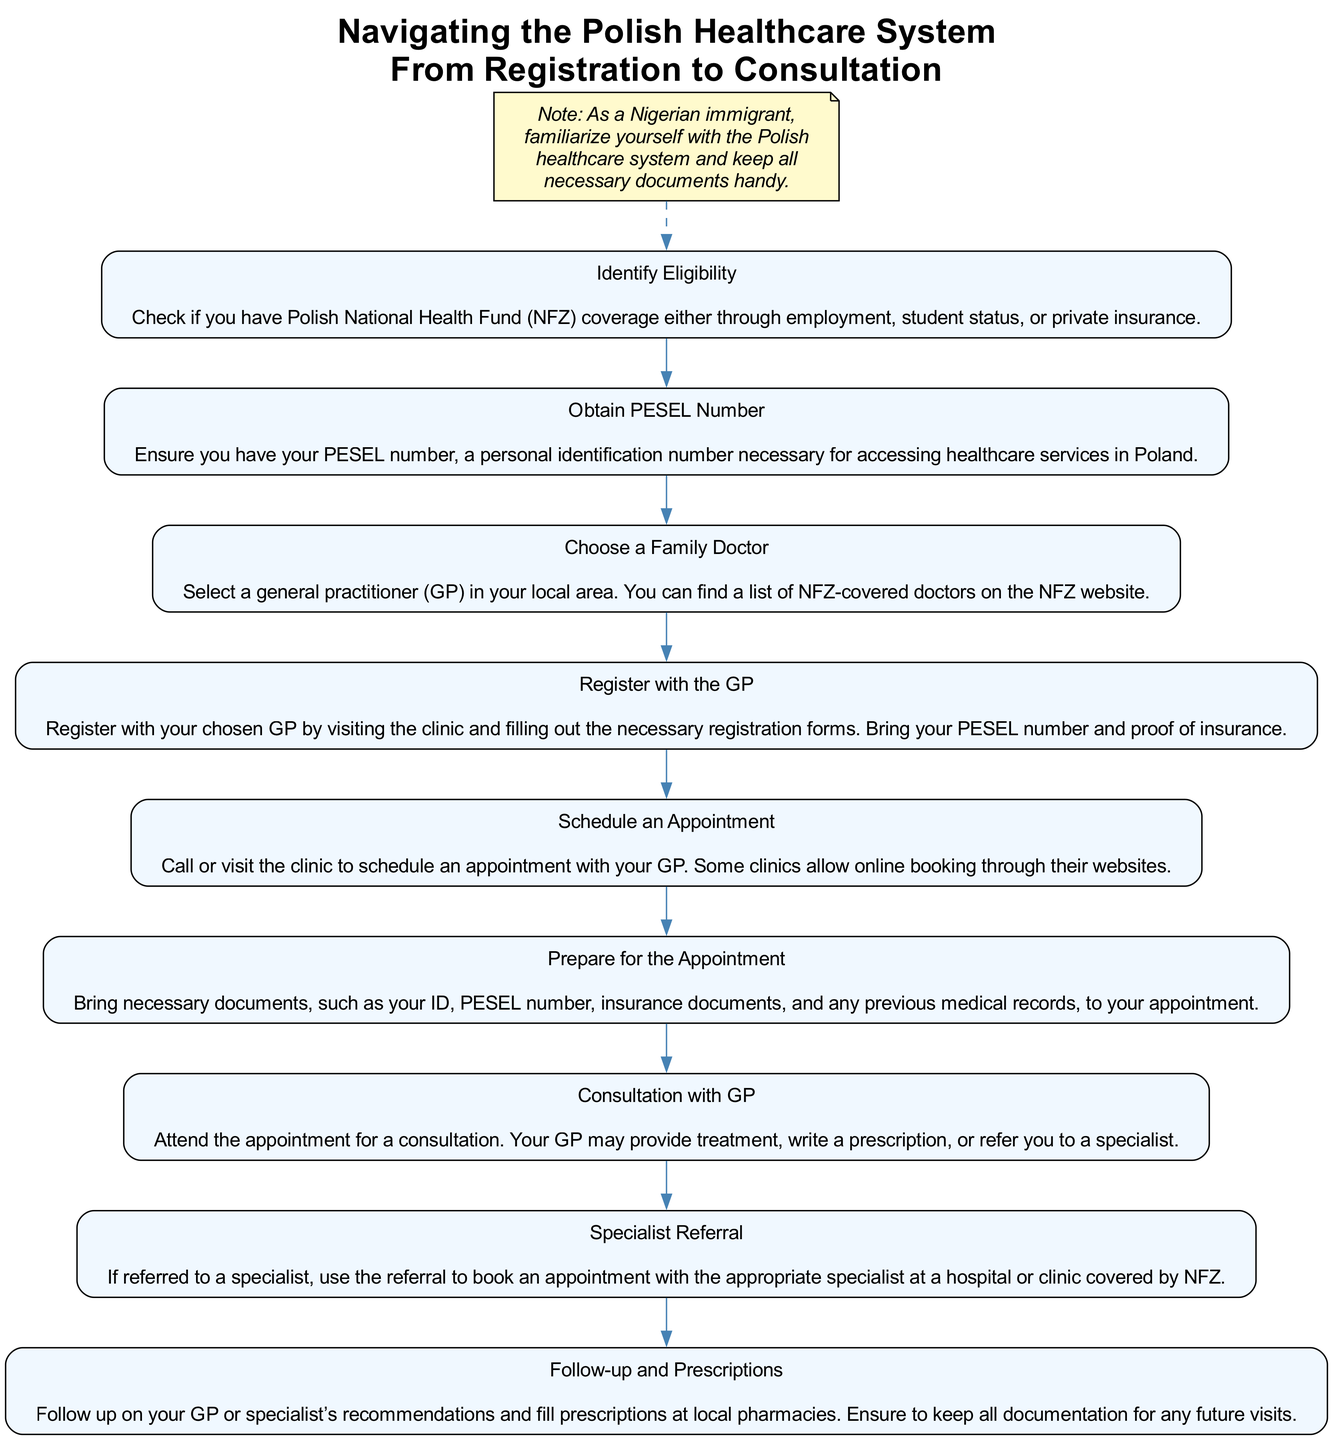What is the first step in the process? The diagram begins with the step labeled "Identify Eligibility," indicating that the first action to take is checking eligibility for healthcare coverage.
Answer: Identify Eligibility How many steps are in the diagram? By counting each unique step represented in the diagram, there are a total of 9 steps from registration to consultation.
Answer: 9 What document do you need to bring to register with the GP? The diagram specifies that when registering with the GP, you must bring your PESEL number and proof of insurance, indicating essential documents for this step.
Answer: PESEL number and proof of insurance Which step involves selecting a healthcare provider? The step titled "Choose a Family Doctor" clearly indicates that this is the phase where you select a general practitioner in your area.
Answer: Choose a Family Doctor What do you do if referred to a specialist? The diagram indicates that if referred to a specialist, you should use the referral to book an appointment with the appropriate specialist.
Answer: Book an appointment with the specialist What must you prepare before the consultation with the GP? According to the diagram, before the appointment, you should prepare documents such as your ID, PESEL number, and insurance documents, indicating the necessary paperwork.
Answer: ID, PESEL number, insurance documents What color is used for the note emphasizing the immigrant perspective? The diagram uses a light yellow color (#FFFACD) for the note that highlights the importance of familiarizing oneself with the healthcare system as an immigrant.
Answer: Light yellow (#FFFACD) Which step comes after scheduling an appointment? Following the schedule appointment step is the "Prepare for the Appointment" step, showing the sequence of preparing before the actual consultation.
Answer: Prepare for the Appointment What information does the note provide regarding the healthcare system? The note stresses the importance of familiarization with the Polish healthcare system and keeping necessary documents handy, which is crucial for immigrants navigating this system.
Answer: Familiarize with the healthcare system and keep documents handy 